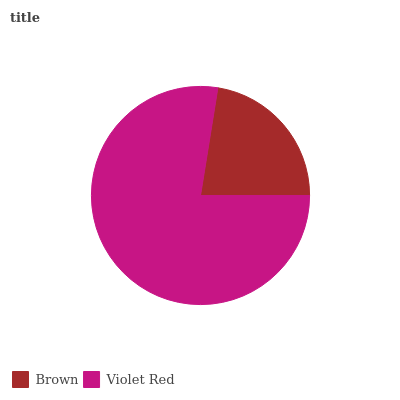Is Brown the minimum?
Answer yes or no. Yes. Is Violet Red the maximum?
Answer yes or no. Yes. Is Violet Red the minimum?
Answer yes or no. No. Is Violet Red greater than Brown?
Answer yes or no. Yes. Is Brown less than Violet Red?
Answer yes or no. Yes. Is Brown greater than Violet Red?
Answer yes or no. No. Is Violet Red less than Brown?
Answer yes or no. No. Is Violet Red the high median?
Answer yes or no. Yes. Is Brown the low median?
Answer yes or no. Yes. Is Brown the high median?
Answer yes or no. No. Is Violet Red the low median?
Answer yes or no. No. 